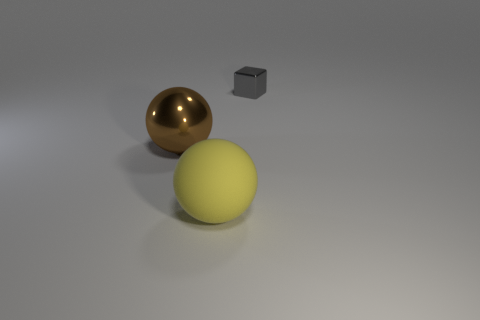Add 1 big brown objects. How many objects exist? 4 Subtract all cubes. How many objects are left? 2 Add 3 small green objects. How many small green objects exist? 3 Subtract 0 green blocks. How many objects are left? 3 Subtract all gray objects. Subtract all big metallic spheres. How many objects are left? 1 Add 2 tiny gray things. How many tiny gray things are left? 3 